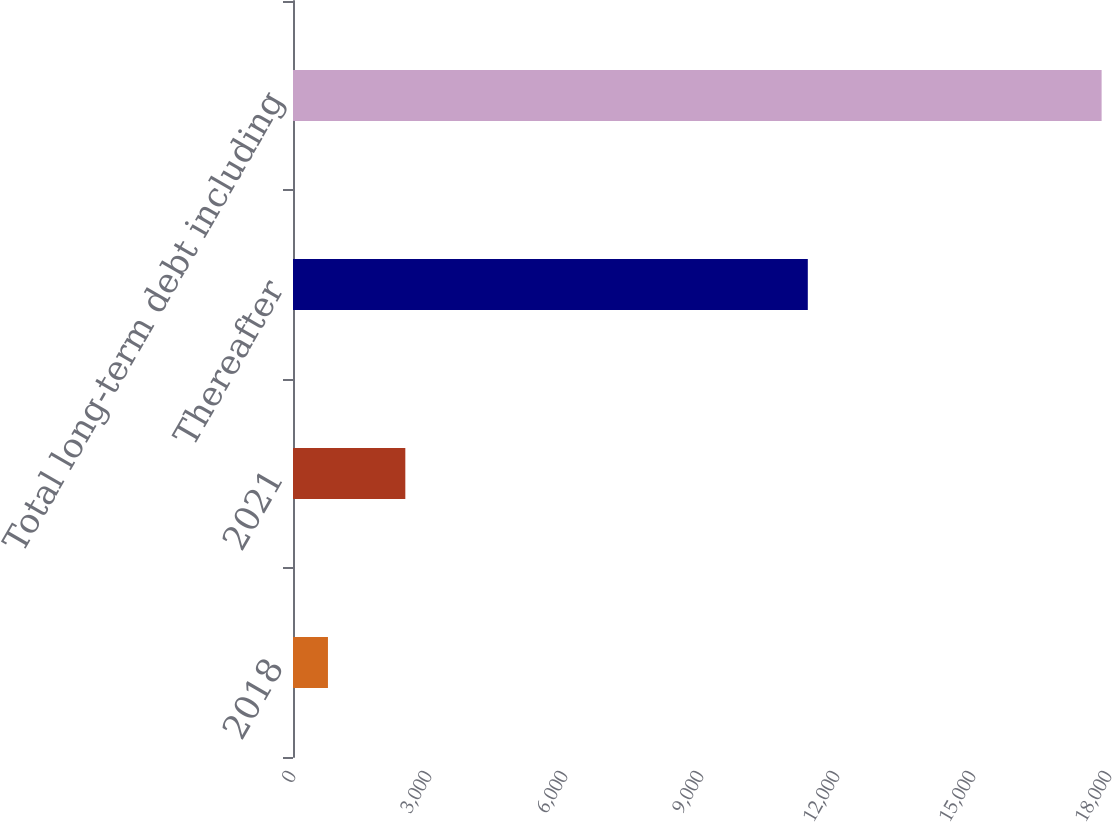Convert chart to OTSL. <chart><loc_0><loc_0><loc_500><loc_500><bar_chart><fcel>2018<fcel>2021<fcel>Thereafter<fcel>Total long-term debt including<nl><fcel>771<fcel>2477.6<fcel>11356<fcel>17837<nl></chart> 